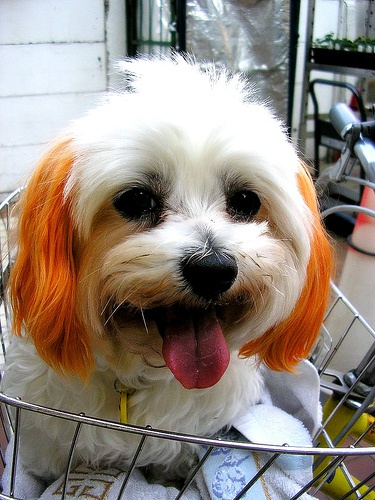Describe the objects in this image and their specific colors. I can see dog in darkgray, white, gray, and black tones, potted plant in darkgray, black, teal, and darkgreen tones, and chair in darkgray, black, gray, purple, and navy tones in this image. 